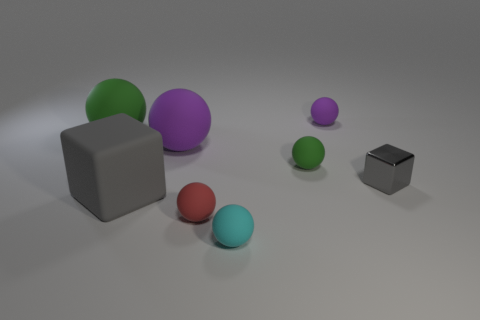Add 1 small brown metallic objects. How many objects exist? 9 Subtract all purple matte spheres. How many spheres are left? 4 Subtract all blue cylinders. How many green spheres are left? 2 Subtract all purple balls. How many balls are left? 4 Subtract all cubes. How many objects are left? 6 Subtract 5 spheres. How many spheres are left? 1 Subtract all green spheres. Subtract all gray cylinders. How many spheres are left? 4 Subtract all small cyan things. Subtract all tiny gray metallic things. How many objects are left? 6 Add 2 tiny cyan balls. How many tiny cyan balls are left? 3 Add 5 small yellow blocks. How many small yellow blocks exist? 5 